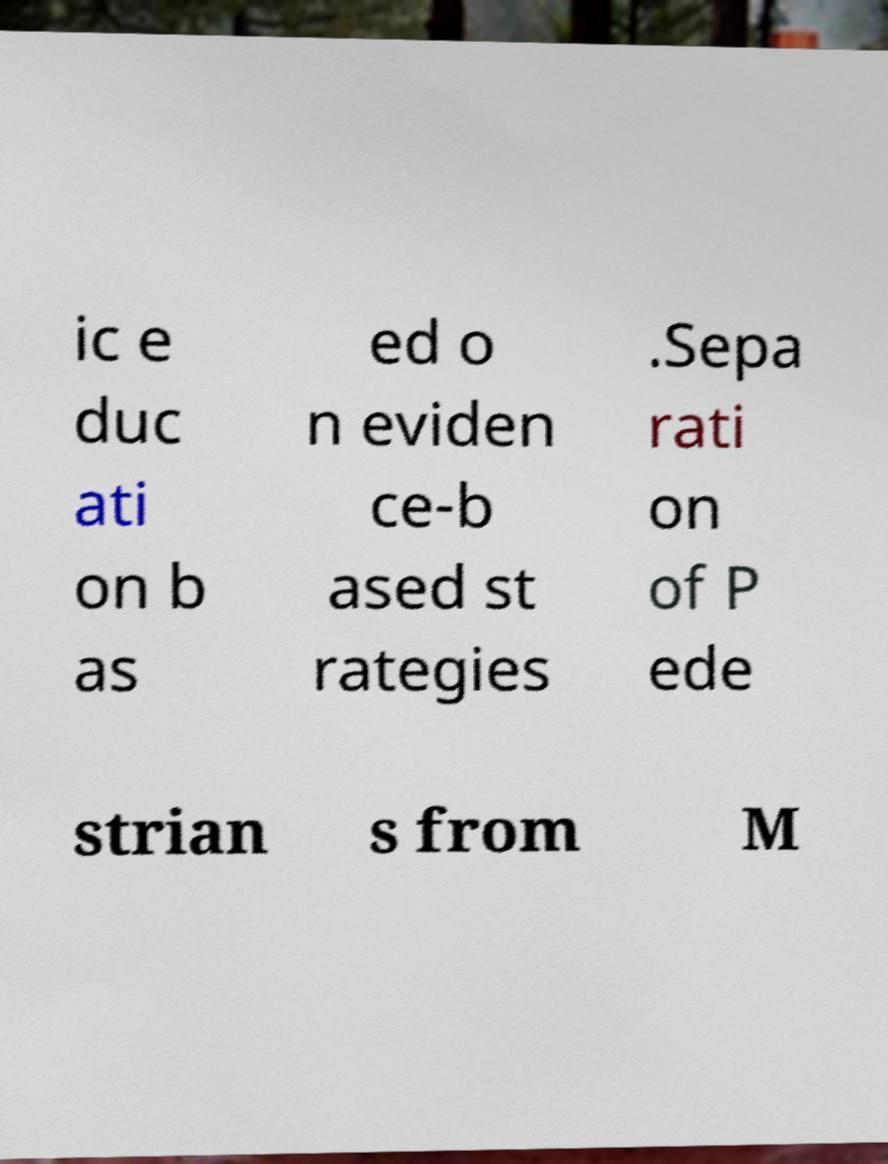Please identify and transcribe the text found in this image. ic e duc ati on b as ed o n eviden ce-b ased st rategies .Sepa rati on of P ede strian s from M 